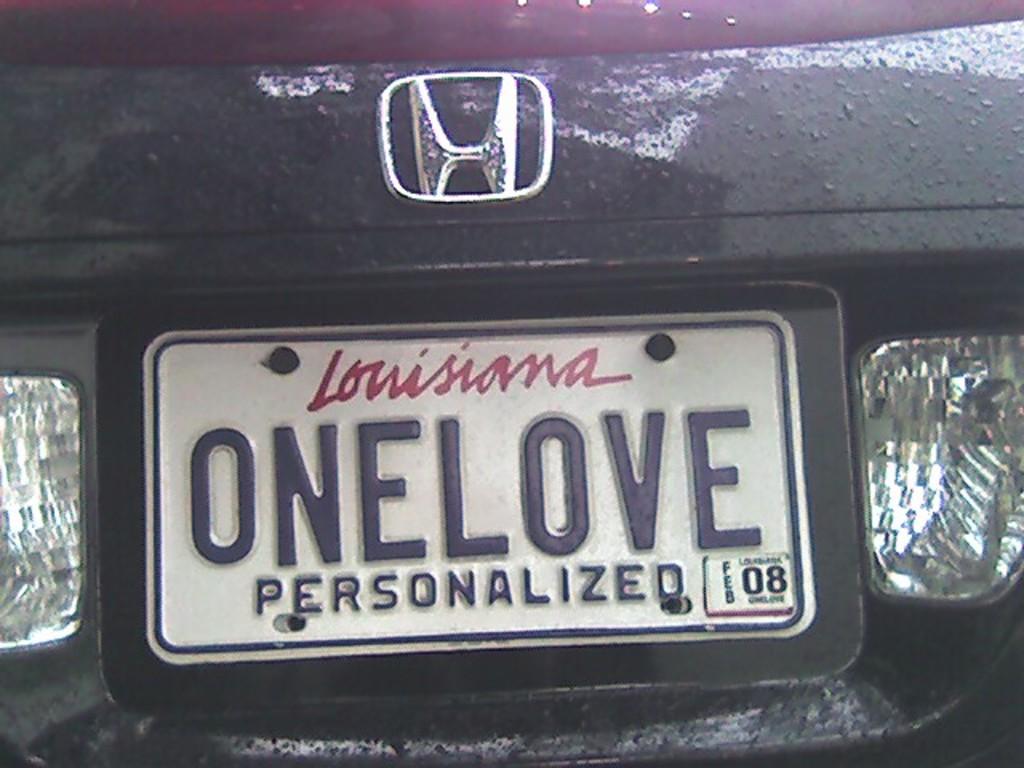What year does it expire?
Your response must be concise. 08. 